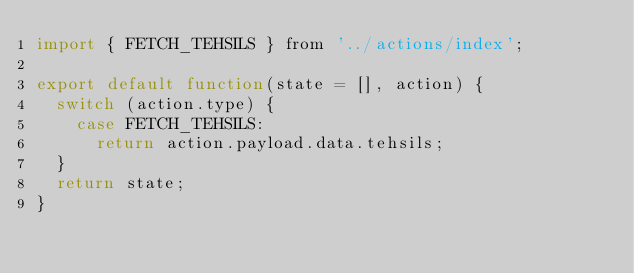Convert code to text. <code><loc_0><loc_0><loc_500><loc_500><_JavaScript_>import { FETCH_TEHSILS } from '../actions/index';

export default function(state = [], action) {
  switch (action.type) {
    case FETCH_TEHSILS:
      return action.payload.data.tehsils;
  }
  return state;
}
</code> 